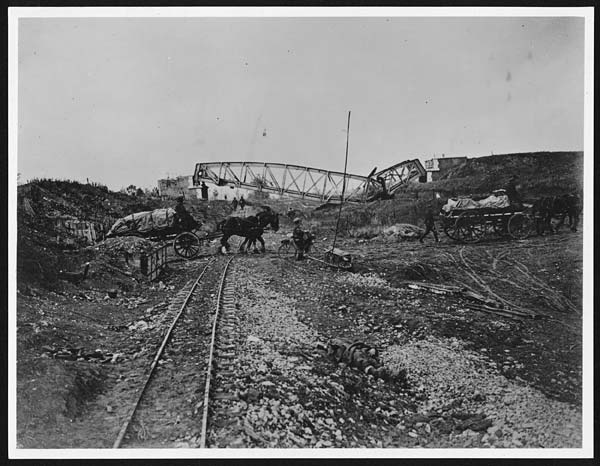Describe the objects in this image and their specific colors. I can see horse in black, gray, and lightgray tones, bicycle in black and gray tones, people in black and gray tones, people in black and gray tones, and people in black, gray, and darkgray tones in this image. 